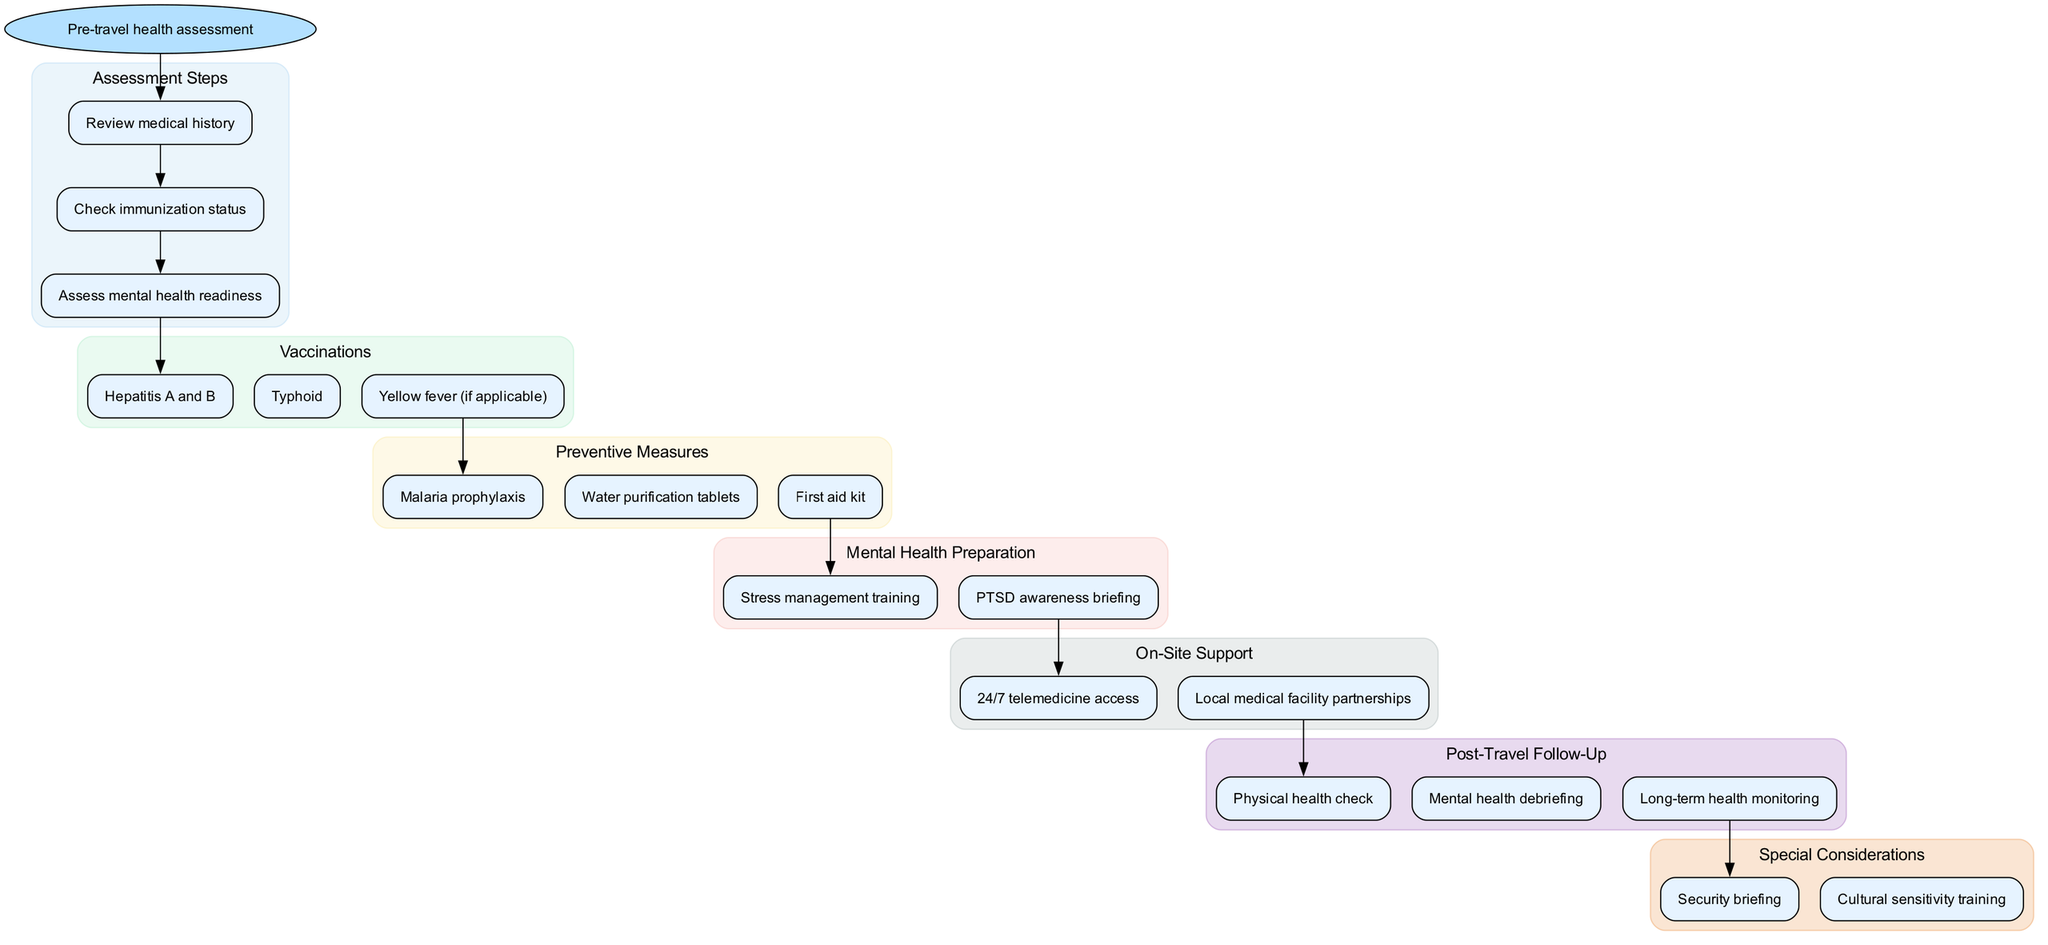What is the starting point of the clinical pathway? The diagram begins with the node labeled "Pre-travel health assessment", indicating this is the starting activity in the pathway.
Answer: Pre-travel health assessment How many vaccination steps are listed in the diagram? The vaccinations section contains three distinct nodes, which represent the vaccination steps, therefore the count is three.
Answer: 3 What is the first preventive measure listed in the diagram? In the preventive measures section, the first preventive measure indicated is "Malaria prophylaxis", referring to the first node in that subsection.
Answer: Malaria prophylaxis What is the last activity listed in the post-travel follow-up section? The last node in the post-travel follow-up section displays "Long-term health monitoring", which indicates it is the final step in that group.
Answer: Long-term health monitoring Which support is accessible on-site according to the diagram? The diagram indicates "24/7 telemedicine access" as one of the forms of on-site support, representing continuous medical assistance.
Answer: 24/7 telemedicine access What special consideration is required before traveling? The special considerations section specifies "Security briefing" as a necessary preparation to be completed before travel, highlighting its importance for safety.
Answer: Security briefing What follows after the mental health preparation stage? According to the flow, the next stage that follows the mental health preparation section is the "On-Site Support", which indicates the sequential flow of activities.
Answer: On-Site Support How many steps are there in the assessment section? The assessment section contains three listed steps: "Review medical history", "Check immunization status", and "Assess mental health readiness", totaling three individual assessment steps.
Answer: 3 Which vaccination is listed if yellow fever is applicable? The vaccinations denote "Yellow fever (if applicable)" as one of the potential vaccinations that may be administered based on the travel destination.
Answer: Yellow fever (if applicable) 